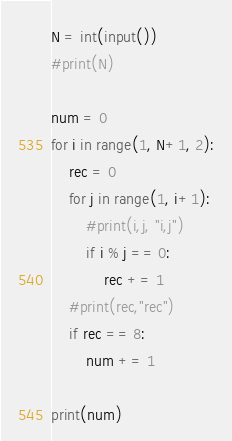Convert code to text. <code><loc_0><loc_0><loc_500><loc_500><_Python_>N = int(input())
#print(N)

num = 0
for i in range(1, N+1, 2):
    rec = 0
    for j in range(1, i+1):
        #print(i,j, "i,j")
        if i % j == 0:
            rec += 1
    #print(rec,"rec")
    if rec == 8:
        num += 1
        
print(num)</code> 